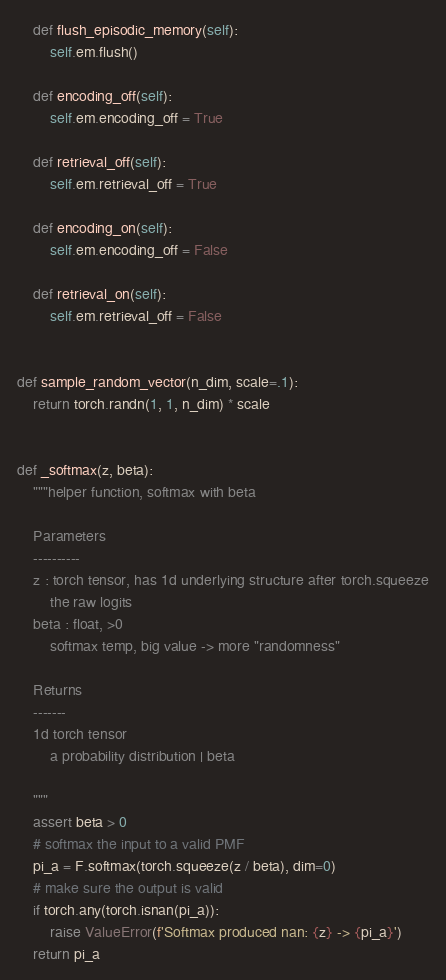Convert code to text. <code><loc_0><loc_0><loc_500><loc_500><_Python_>    def flush_episodic_memory(self):
        self.em.flush()

    def encoding_off(self):
        self.em.encoding_off = True

    def retrieval_off(self):
        self.em.retrieval_off = True

    def encoding_on(self):
        self.em.encoding_off = False

    def retrieval_on(self):
        self.em.retrieval_off = False


def sample_random_vector(n_dim, scale=.1):
    return torch.randn(1, 1, n_dim) * scale


def _softmax(z, beta):
    """helper function, softmax with beta

    Parameters
    ----------
    z : torch tensor, has 1d underlying structure after torch.squeeze
        the raw logits
    beta : float, >0
        softmax temp, big value -> more "randomness"

    Returns
    -------
    1d torch tensor
        a probability distribution | beta

    """
    assert beta > 0
    # softmax the input to a valid PMF
    pi_a = F.softmax(torch.squeeze(z / beta), dim=0)
    # make sure the output is valid
    if torch.any(torch.isnan(pi_a)):
        raise ValueError(f'Softmax produced nan: {z} -> {pi_a}')
    return pi_a
</code> 